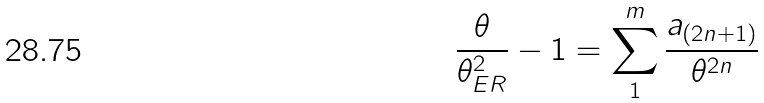<formula> <loc_0><loc_0><loc_500><loc_500>\frac { \theta } { \theta _ { E R } ^ { 2 } } - 1 = \sum _ { 1 } ^ { m } \frac { a _ { ( 2 n + 1 ) } } { \theta ^ { 2 n } }</formula> 